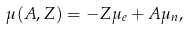<formula> <loc_0><loc_0><loc_500><loc_500>\mu ( A , Z ) = - Z \mu _ { e } + A \mu _ { n } ,</formula> 